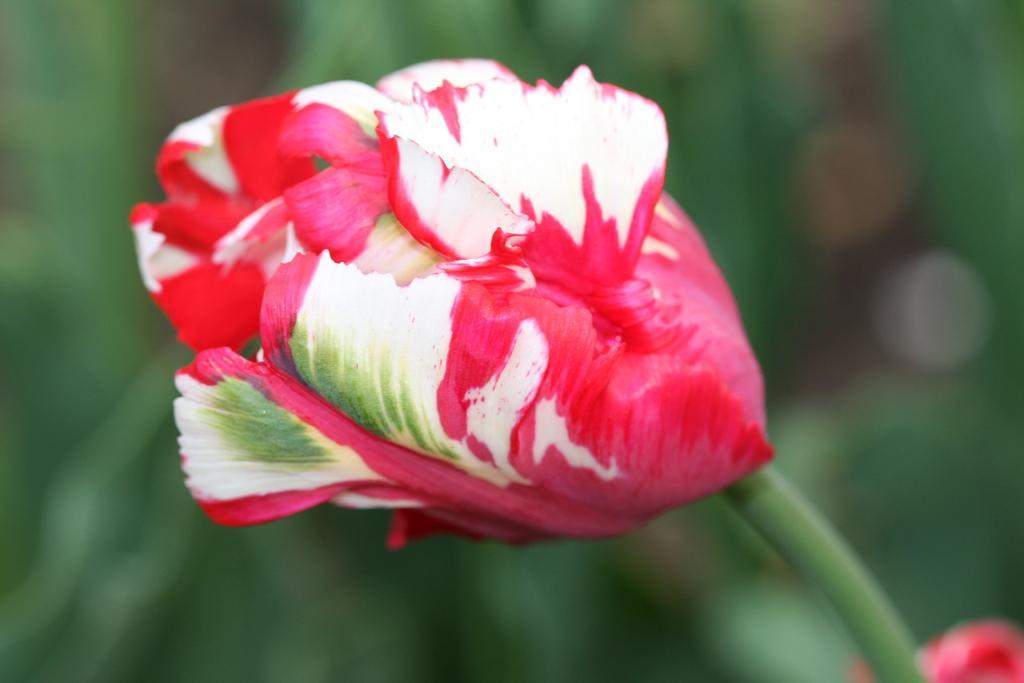Can you describe this image briefly? In this image in front there is a flower with stem. At the bottom of the image there is another flower and the background of the image is blur. 